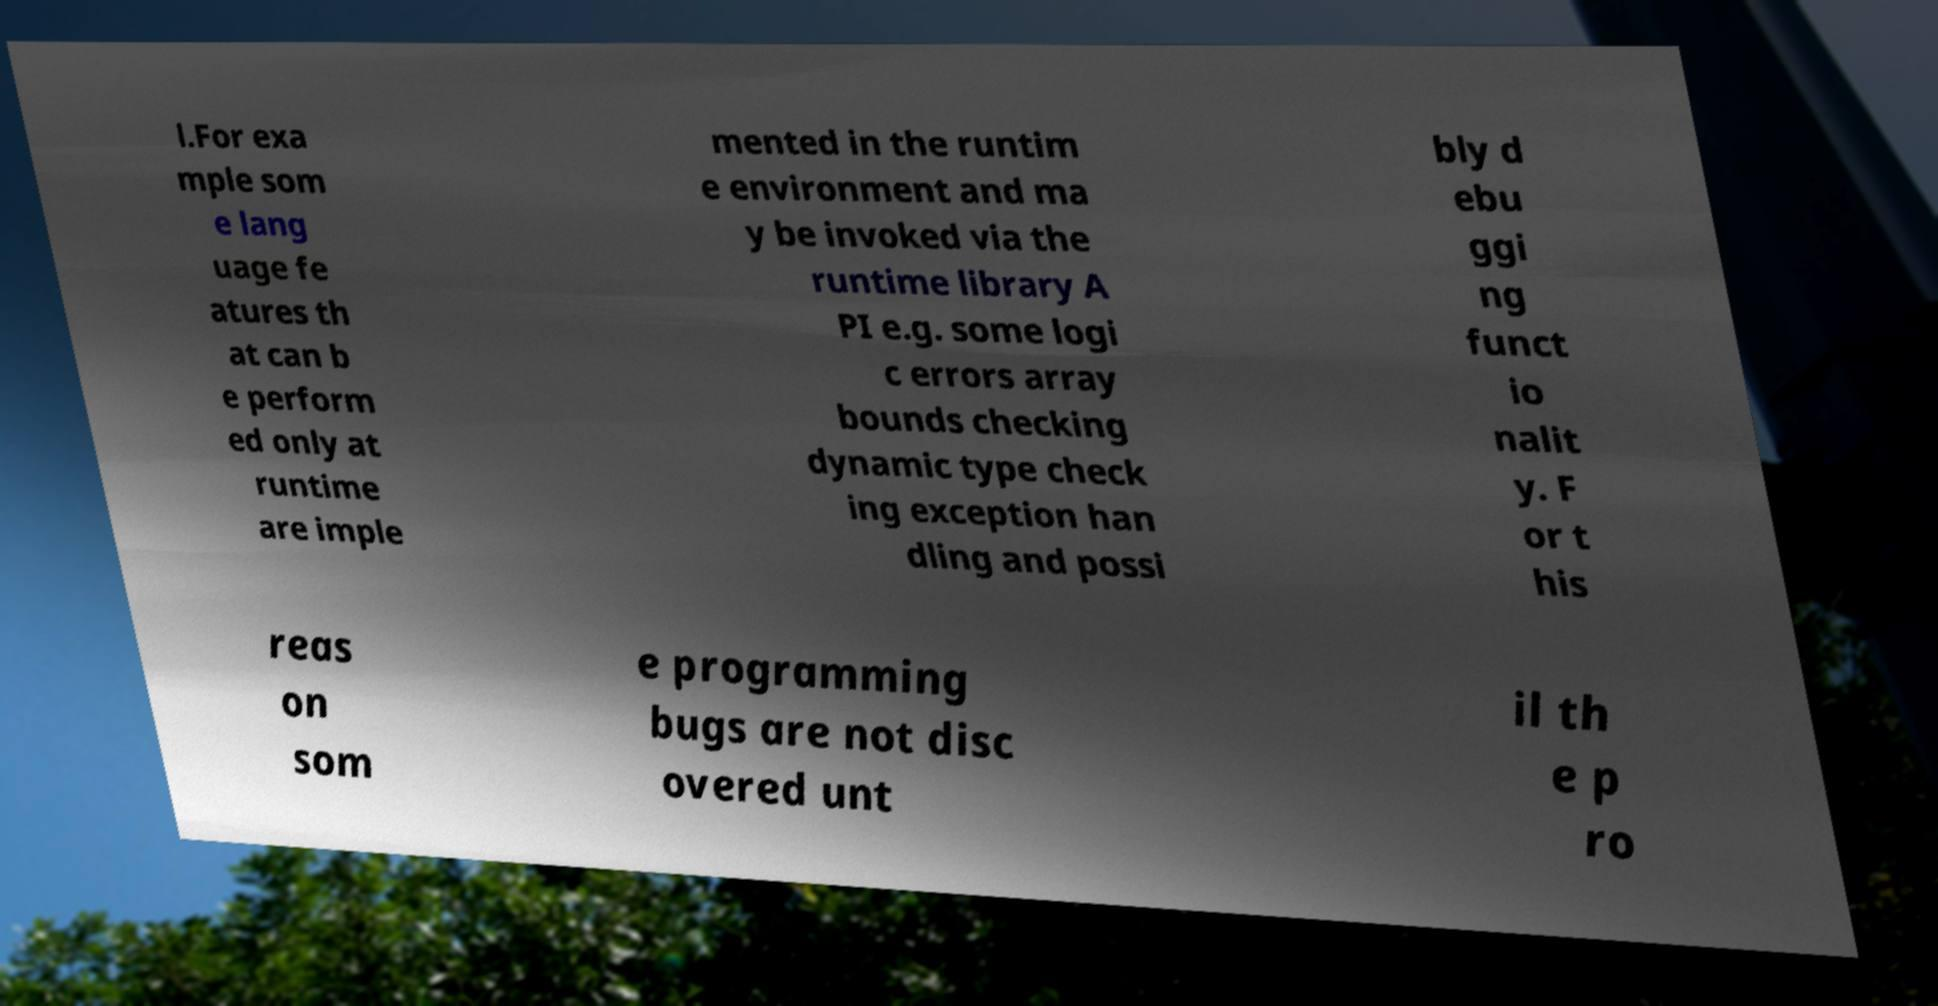Please identify and transcribe the text found in this image. l.For exa mple som e lang uage fe atures th at can b e perform ed only at runtime are imple mented in the runtim e environment and ma y be invoked via the runtime library A PI e.g. some logi c errors array bounds checking dynamic type check ing exception han dling and possi bly d ebu ggi ng funct io nalit y. F or t his reas on som e programming bugs are not disc overed unt il th e p ro 